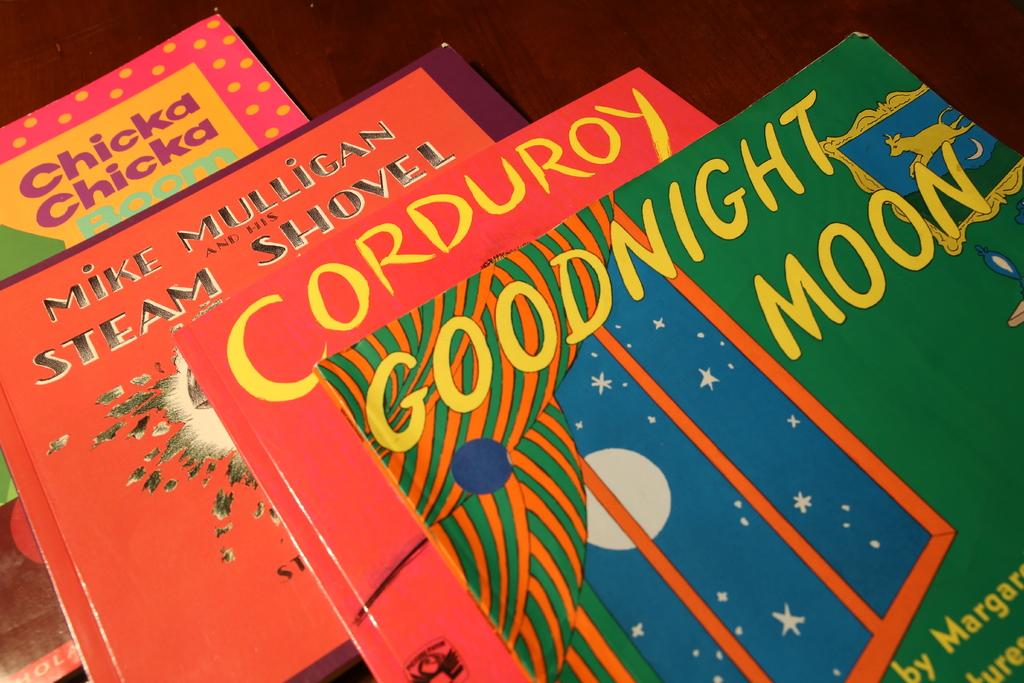Who has a steam shovel?
Your answer should be compact. Mike mulligan. What is the title of the green book?
Offer a very short reply. Goodnight moon. 